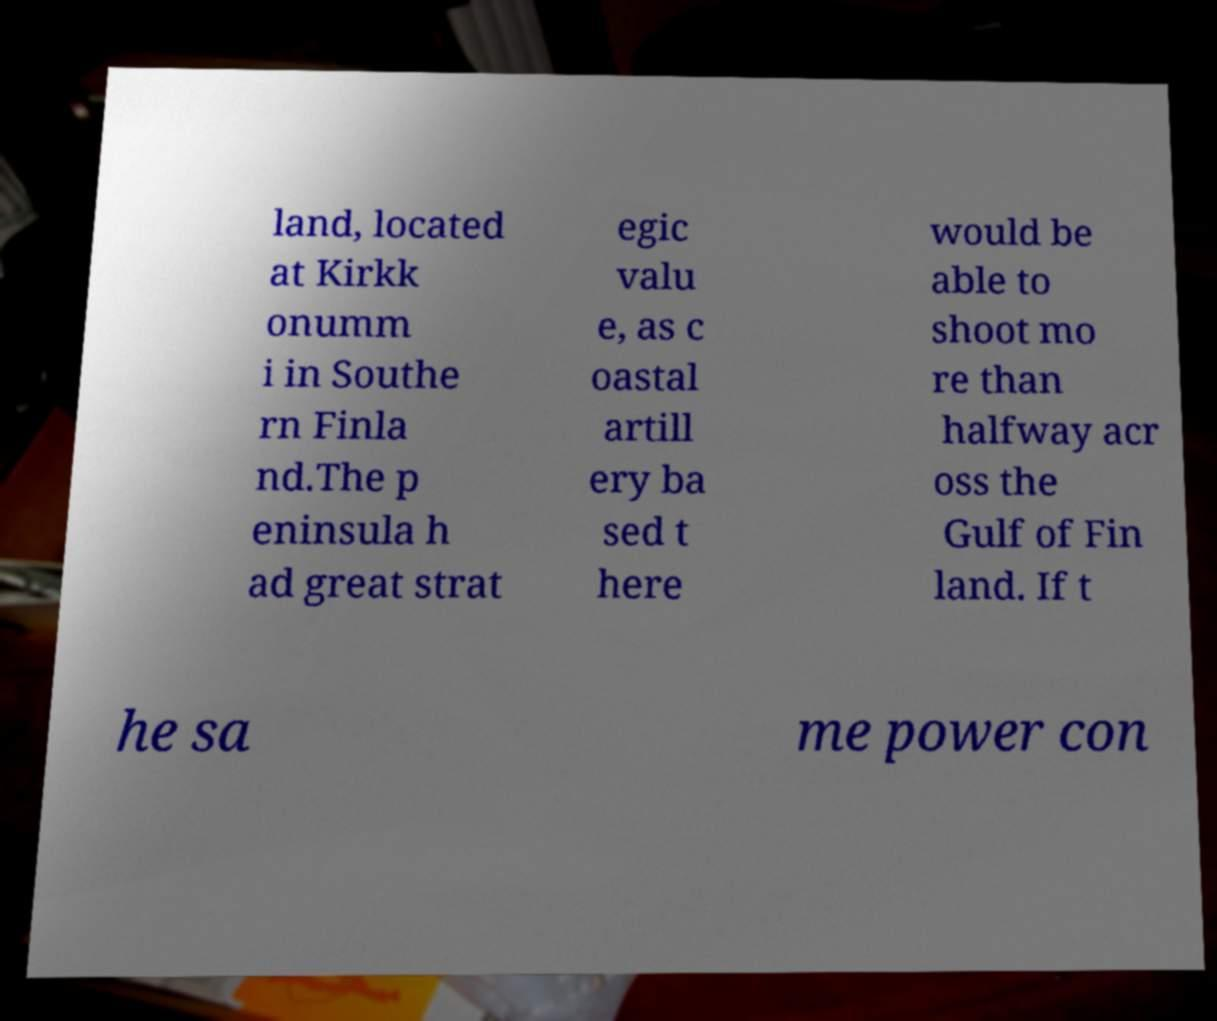Can you accurately transcribe the text from the provided image for me? land, located at Kirkk onumm i in Southe rn Finla nd.The p eninsula h ad great strat egic valu e, as c oastal artill ery ba sed t here would be able to shoot mo re than halfway acr oss the Gulf of Fin land. If t he sa me power con 